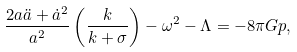<formula> <loc_0><loc_0><loc_500><loc_500>\frac { 2 a \ddot { a } + \dot { a } ^ { 2 } } { a ^ { 2 } } \left ( \frac { k } { k + \sigma } \right ) - \omega ^ { 2 } - \Lambda = - 8 \pi G p ,</formula> 